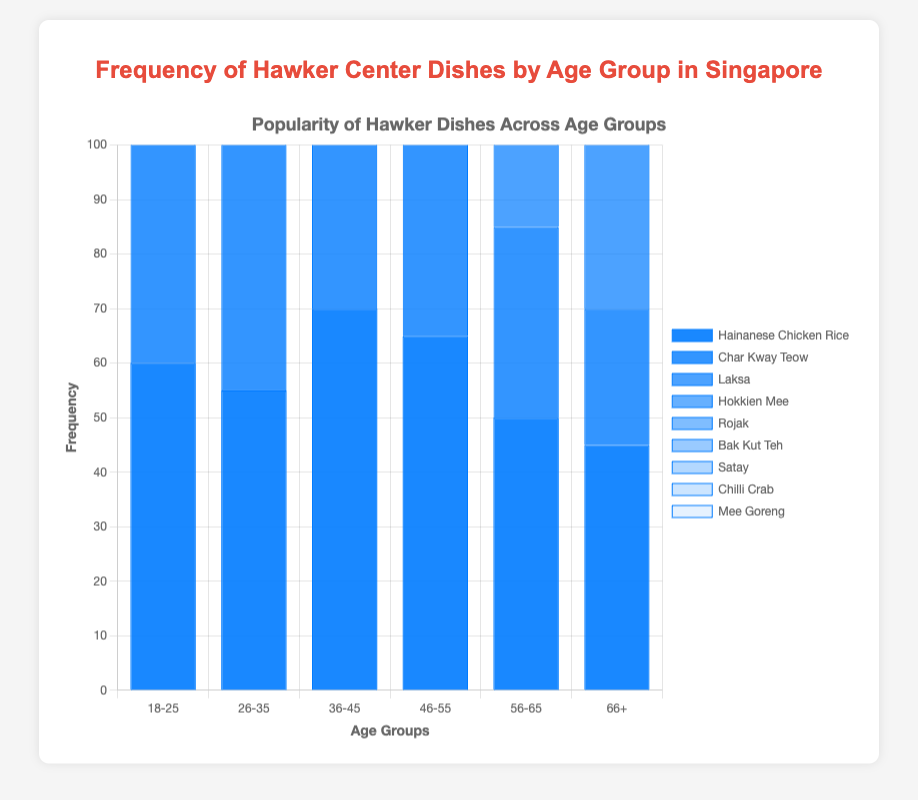What is the most frequently consumed dish among the youngest age group (18-25)? Among the youngest age group (18-25), "Mee Goreng" has the highest frequency with 65.
Answer: Mee Goreng For the age group 36-45, which dish is less popular: Satay or Char Kway Teow? In the 36-45 age group, Satay has a frequency of 45, while Char Kway Teow has a frequency of 55, making Satay less popular.
Answer: Satay Using the first and last age groups (18-25 and 66+), which dish shows an increasing trend in consumption? By comparing the frequencies, "Rojak" shows an increasing trend, from 30 in the 18-25 group to 60 in the 66+ group.
Answer: Rojak What is the combined frequency of Laksa and Bak Kut Teh for the age group 46-55? Adding the frequencies of Laksa (70) and Bak Kut Teh (50) for the 46-55 age group gives a total of 120.
Answer: 120 Which dish has the least variation in frequency across age groups? Hokkien Mee shows the least variation, with frequencies ranging from 40 to 60.
Answer: Hokkien Mee For the age group 56-65, which dish is consumed more frequently: Chilli Crab or Hokkien Mee? In the 56-65 age group, Hokkien Mee has a frequency of 60, while Chilli Crab has 45, making Hokkien Mee more frequently consumed.
Answer: Hokkien Mee What is the difference in frequency of Char Kway Teow between the 26-35 and 66+ age groups? The frequency of Char Kway Teow is 60 for the 26-35 age group and 25 for the 66+ age group, so the difference is 60 - 25 = 35.
Answer: 35 What is the average frequency of Hainanese Chicken Rice across all age groups? Summing the frequencies of Hainanese Chicken Rice across all age groups (60, 55, 70, 65, 50, 45) and dividing by 6 gives an average of 345 / 6 = 57.5.
Answer: 57.5 Which age group prefers Bak Kut Teh the most? The 66+ age group prefers Bak Kut Teh the most, with a frequency of 60.
Answer: 66+ How many age groups have a preference for Hainanese Chicken Rice over 50? The age groups 18-25, 26-35, 36-45, and 46-55 have frequencies of 60, 55, 70, and 65, respectively, all over 50. So, 4 age groups prefer it over 50.
Answer: 4 